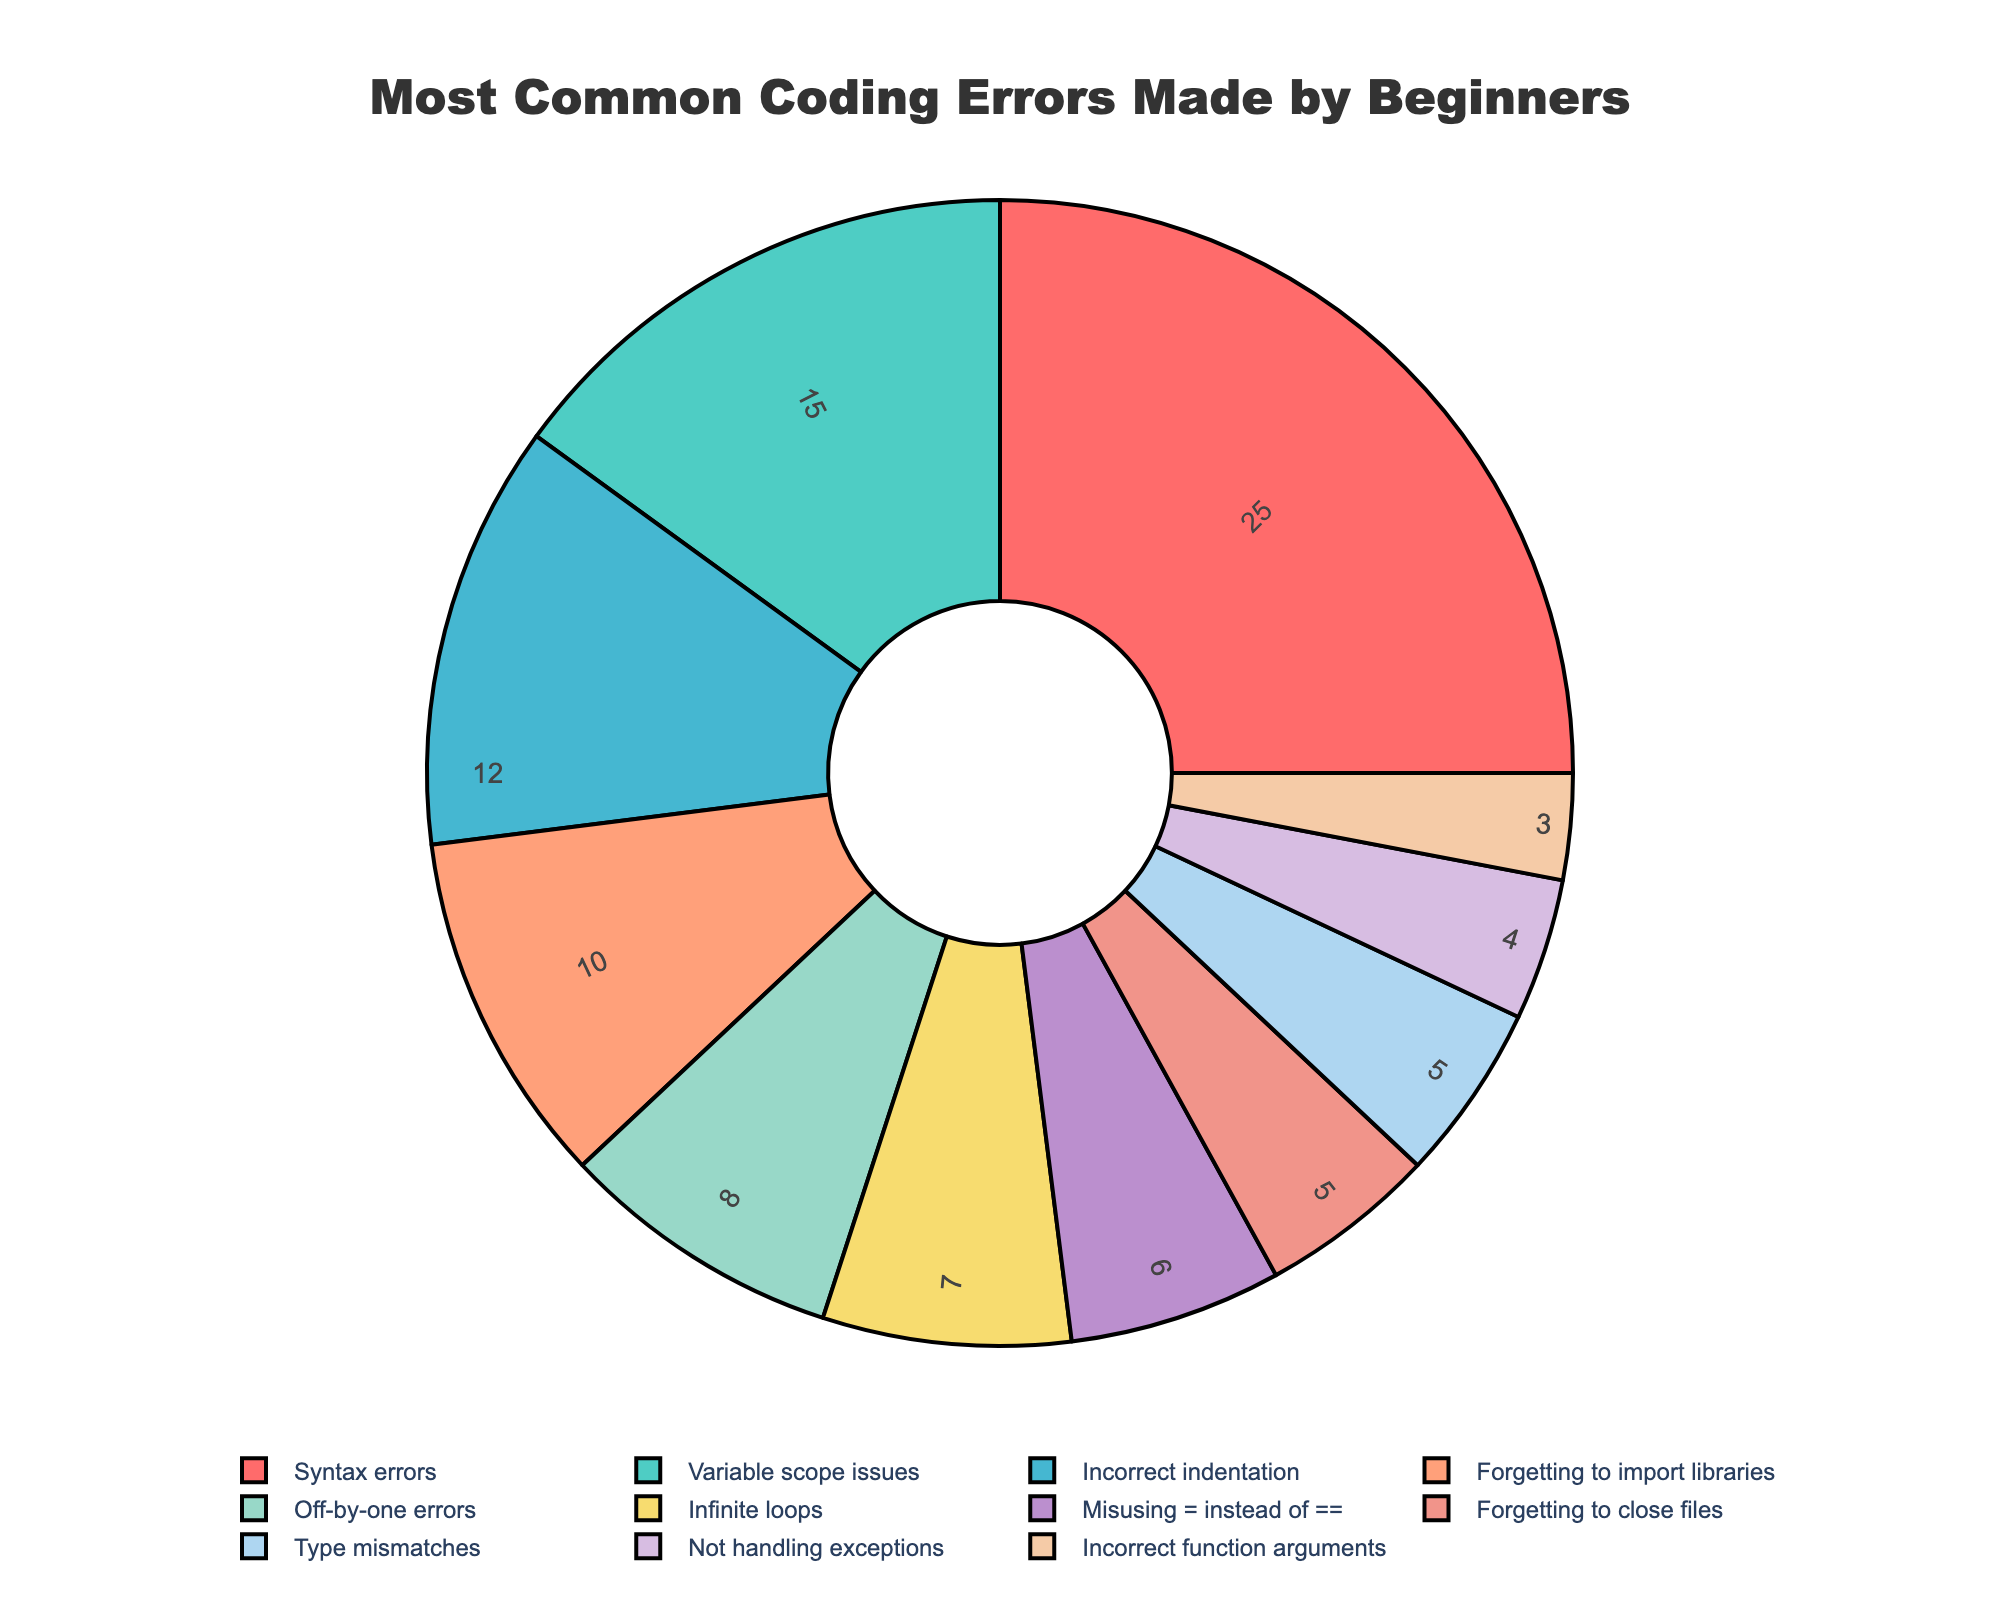Which type of coding error is the most common? The largest segment on the pie chart represents Syntax errors, indicating it is the most common type.
Answer: Syntax errors What percentage of errors are related to variable scope issues? The pie chart shows that variable scope issues constitute 15% of the errors.
Answer: 15% Which error types combined make up close to half the total errors? Syntax errors (25%) and variable scope issues (15%) combined make up 40% of the total errors, close to half. Adding Incorrect indentation (12%) results in 52%, also near half.
Answer: Syntax errors, Variable scope issues, Incorrect indentation How much more common are syntax errors compared to forgetting to import libraries? Syntax errors account for 25%, and forgetting to import libraries is 10%. The difference is 25% - 10% = 15%.
Answer: 15% What is the combined percentage of errors related to infinite loops and misusing = instead of ==? Infinite loops account for 7%, and misusing = instead of == is 6%. Adding them gives 7% + 6% = 13%.
Answer: 13% Are there any error types that have the same percentage? Yes, forgetting to close files and type mismatches both account for 5% of the errors.
Answer: Yes, forgetting to close files and type mismatches Is the percentage of incorrect function arguments more or less than off-by-one errors? Incorrect function arguments account for 3%, while off-by-one errors are 8%. Therefore, incorrect function arguments are less common.
Answer: Less What is the smallest error category and its percentage? The smallest segment on the pie chart represents incorrect function arguments, accounting for 3%.
Answer: Incorrect function arguments, 3% What visual attributes help identify the largest error type? The largest segment's visual attributes include the widest area in the chart, highlighted in a distinct color among all categories.
Answer: Largest area, distinct color How do the percentages for forgetting to close files and not handling exceptions compare? Forgetting to close files is 5%, while not handling exceptions is 4%. Forgetting to close files is slightly more common by 1%.
Answer: Forgetting to close files is 1% more 